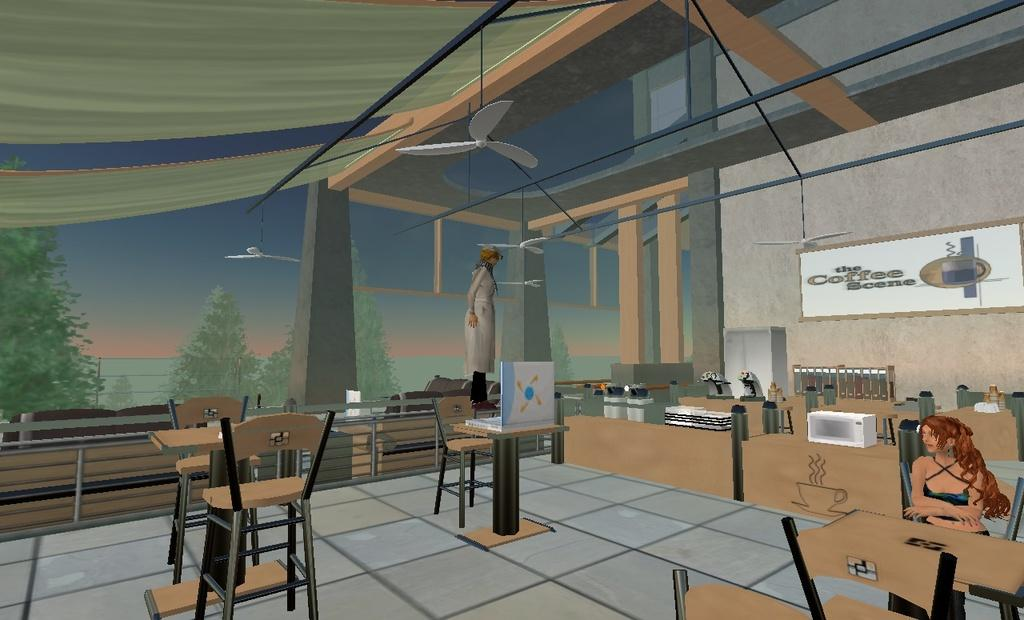What style is used in the image? The image is an anime depiction. Where is the girl located in the image? The girl is sitting on the right side of the image. What is the girl positioned in front of? The girl is in front of a table. What can be seen in the distance in the image? There are trees visible in the background of the image. What account number is associated with the girl in the image? There is no account number associated with the girl in the image, as it is an anime depiction and not a real person. 